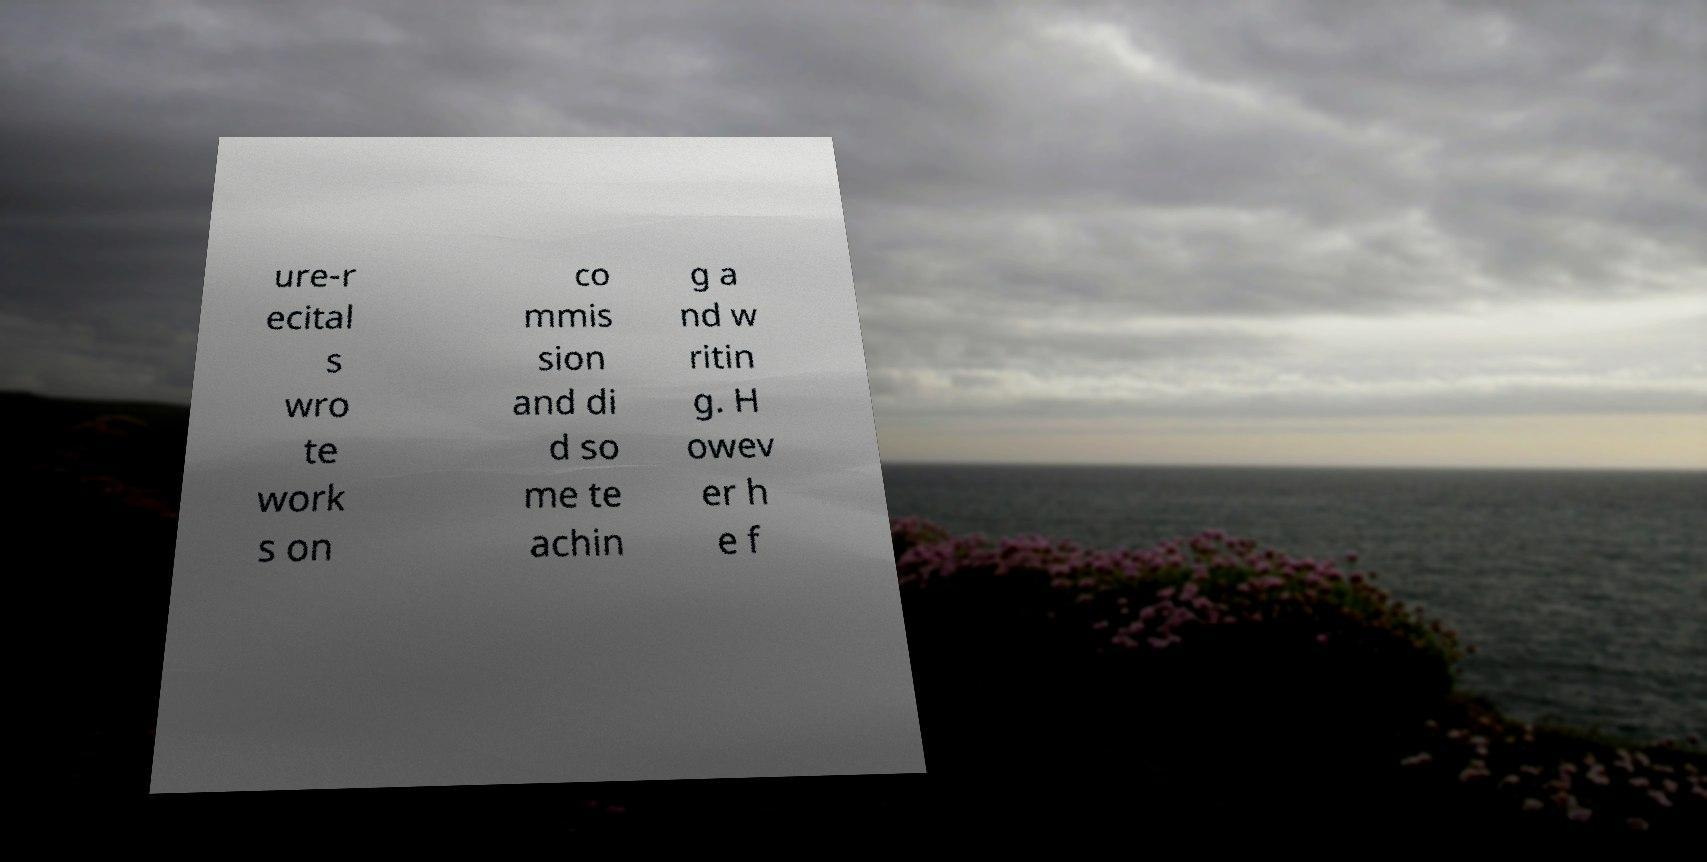Can you accurately transcribe the text from the provided image for me? ure-r ecital s wro te work s on co mmis sion and di d so me te achin g a nd w ritin g. H owev er h e f 